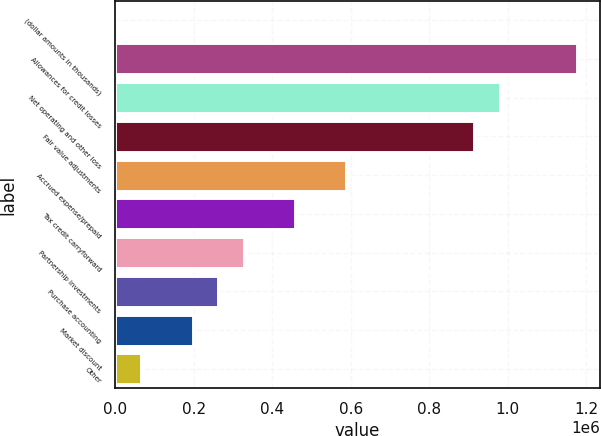Convert chart. <chart><loc_0><loc_0><loc_500><loc_500><bar_chart><fcel>(dollar amounts in thousands)<fcel>Allowances for credit losses<fcel>Net operating and other loss<fcel>Fair value adjustments<fcel>Accrued expense/prepaid<fcel>Tax credit carryforward<fcel>Partnership investments<fcel>Purchase accounting<fcel>Market discount<fcel>Other<nl><fcel>2014<fcel>1.17532e+06<fcel>979770<fcel>914586<fcel>588667<fcel>458300<fcel>327932<fcel>262749<fcel>197565<fcel>67197.7<nl></chart> 